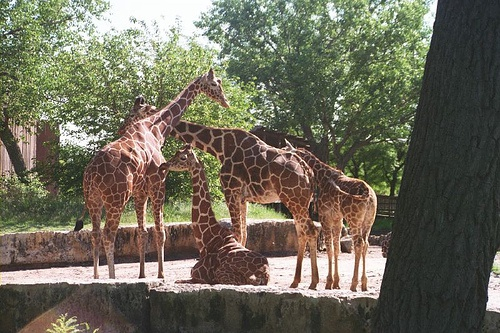Describe the objects in this image and their specific colors. I can see giraffe in darkgray, maroon, gray, brown, and lightgray tones, giraffe in darkgray, maroon, gray, and black tones, giraffe in darkgray, maroon, brown, and gray tones, and giraffe in darkgray, gray, maroon, and brown tones in this image. 